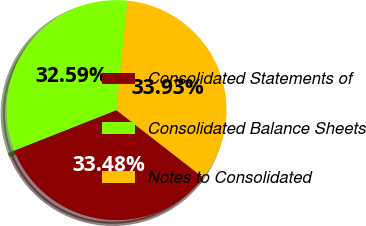Convert chart. <chart><loc_0><loc_0><loc_500><loc_500><pie_chart><fcel>Consolidated Statements of<fcel>Consolidated Balance Sheets<fcel>Notes to Consolidated<nl><fcel>33.48%<fcel>32.59%<fcel>33.93%<nl></chart> 